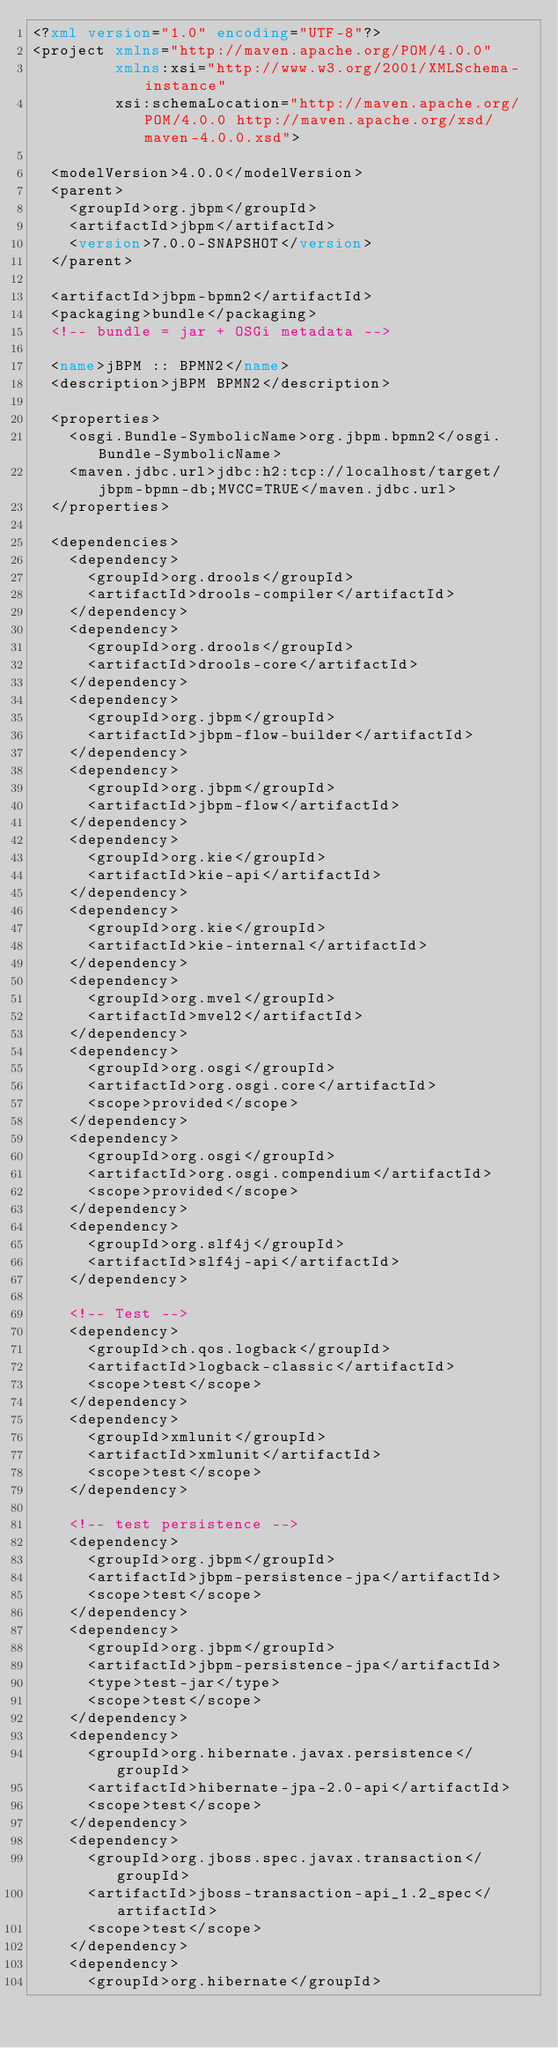Convert code to text. <code><loc_0><loc_0><loc_500><loc_500><_XML_><?xml version="1.0" encoding="UTF-8"?>
<project xmlns="http://maven.apache.org/POM/4.0.0"
         xmlns:xsi="http://www.w3.org/2001/XMLSchema-instance"
         xsi:schemaLocation="http://maven.apache.org/POM/4.0.0 http://maven.apache.org/xsd/maven-4.0.0.xsd">

  <modelVersion>4.0.0</modelVersion>
  <parent>
    <groupId>org.jbpm</groupId>
    <artifactId>jbpm</artifactId>
    <version>7.0.0-SNAPSHOT</version>
  </parent>

  <artifactId>jbpm-bpmn2</artifactId>
  <packaging>bundle</packaging>
  <!-- bundle = jar + OSGi metadata -->

  <name>jBPM :: BPMN2</name>
  <description>jBPM BPMN2</description>
  
  <properties>
    <osgi.Bundle-SymbolicName>org.jbpm.bpmn2</osgi.Bundle-SymbolicName>
    <maven.jdbc.url>jdbc:h2:tcp://localhost/target/jbpm-bpmn-db;MVCC=TRUE</maven.jdbc.url>
  </properties>

  <dependencies>
    <dependency>
      <groupId>org.drools</groupId>
      <artifactId>drools-compiler</artifactId>
    </dependency>
    <dependency>
      <groupId>org.drools</groupId>
      <artifactId>drools-core</artifactId>
    </dependency>
    <dependency>
      <groupId>org.jbpm</groupId>
      <artifactId>jbpm-flow-builder</artifactId>
    </dependency>
    <dependency>
      <groupId>org.jbpm</groupId>
      <artifactId>jbpm-flow</artifactId>
    </dependency>
    <dependency>
      <groupId>org.kie</groupId>
      <artifactId>kie-api</artifactId>
    </dependency>
    <dependency>
      <groupId>org.kie</groupId>
      <artifactId>kie-internal</artifactId>
    </dependency>
    <dependency>
      <groupId>org.mvel</groupId>
      <artifactId>mvel2</artifactId>
    </dependency>
    <dependency>
      <groupId>org.osgi</groupId>
      <artifactId>org.osgi.core</artifactId>
      <scope>provided</scope>
    </dependency>
    <dependency>
      <groupId>org.osgi</groupId>
      <artifactId>org.osgi.compendium</artifactId>
      <scope>provided</scope>
    </dependency>
    <dependency>
      <groupId>org.slf4j</groupId>
      <artifactId>slf4j-api</artifactId>
    </dependency>
    
    <!-- Test -->
    <dependency>
      <groupId>ch.qos.logback</groupId>
      <artifactId>logback-classic</artifactId>
      <scope>test</scope>
    </dependency>
    <dependency>
      <groupId>xmlunit</groupId>
      <artifactId>xmlunit</artifactId>
      <scope>test</scope>
    </dependency>
    
    <!-- test persistence -->  
    <dependency>
      <groupId>org.jbpm</groupId>
      <artifactId>jbpm-persistence-jpa</artifactId>
      <scope>test</scope>
    </dependency>
    <dependency>
      <groupId>org.jbpm</groupId>
      <artifactId>jbpm-persistence-jpa</artifactId>
      <type>test-jar</type>
      <scope>test</scope>
    </dependency>
    <dependency>
      <groupId>org.hibernate.javax.persistence</groupId>
      <artifactId>hibernate-jpa-2.0-api</artifactId>
      <scope>test</scope>
    </dependency>
    <dependency>
      <groupId>org.jboss.spec.javax.transaction</groupId>
      <artifactId>jboss-transaction-api_1.2_spec</artifactId>
      <scope>test</scope>
    </dependency>
    <dependency>
      <groupId>org.hibernate</groupId></code> 